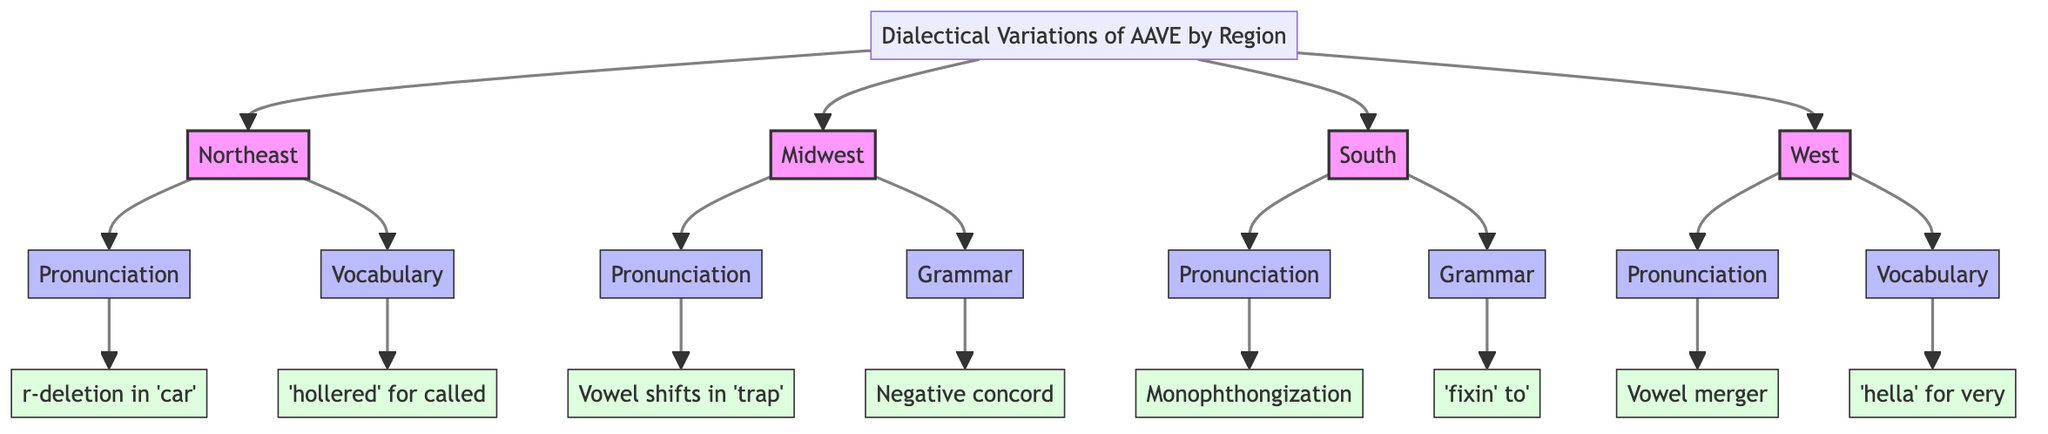What regions are represented in the diagram? The diagram showcases four regions: Northeast, Midwest, South, and West. Each of these regions is connected to the main title node that represents dialectical variations of AAVE.
Answer: Northeast, Midwest, South, West How many distinctive features are shown for the South region? The South region has two distinctive features listed in the diagram: Pronunciation and Grammar. This is determined by counting the features connected to the South region node.
Answer: 2 What is an example of pronunciation in the Northeast region? The diagram specifies that 'r-deletion in words like 'car' (sounds like 'cah')' is an example of pronunciation in the Northeast region. This information is found by looking at the examples listed under the Pronunciation feature for Northeast.
Answer: r-deletion in 'car' Which region features the example "Vowel merger"? The example "Vowel merger" is associated with the West region under the Pronunciation feature. This is identified by tracing the connection from the West node to its Pronunciation feature, then to the example.
Answer: West What are the two types of features used to describe the Midwest region? The Midwest region is described using Pronunciation and Grammar features. This is seen by identifying the two feature nodes directly connected to the Midwest node in the diagram.
Answer: Pronunciation, Grammar Which region uses the term 'hella' and in what context? The West region uses the term 'hella' to mean 'very' or 'a lot of'. This is determined by following the path from the West region to Vocabulary and finding the corresponding example.
Answer: West, 'very' or 'a lot of' What is the distinctive grammatical feature noted in the South region? The South region features the use of 'fixin’ to' to indicate immediate future action as a distinctive grammatical feature. This is captured by looking under the Grammar feature for the South region.
Answer: 'fixin’ to' How does the feature of r-deletion in the Northeast connect to the main topic? The feature of r-deletion in the Northeast connects to the main topic of dialectical variations of AAVE by illustrating a specific phonetic characteristic distinctive to the linguistic habits of speakers in that region. This is shown by directly following the connections in the diagram from AAVE to Northeast and then to Pronunciation and its example.
Answer: Phonetic characteristic of Northeast 